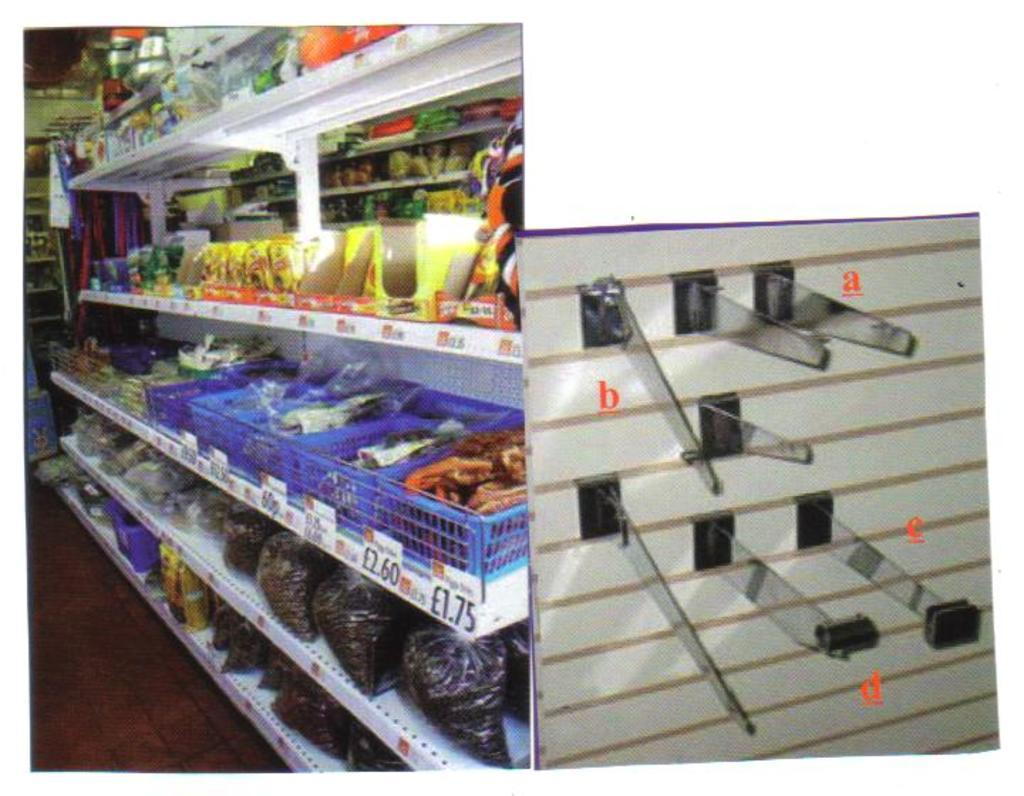<image>
Provide a brief description of the given image. A store is selling various of items with prices at 1.75 and 2.60. 